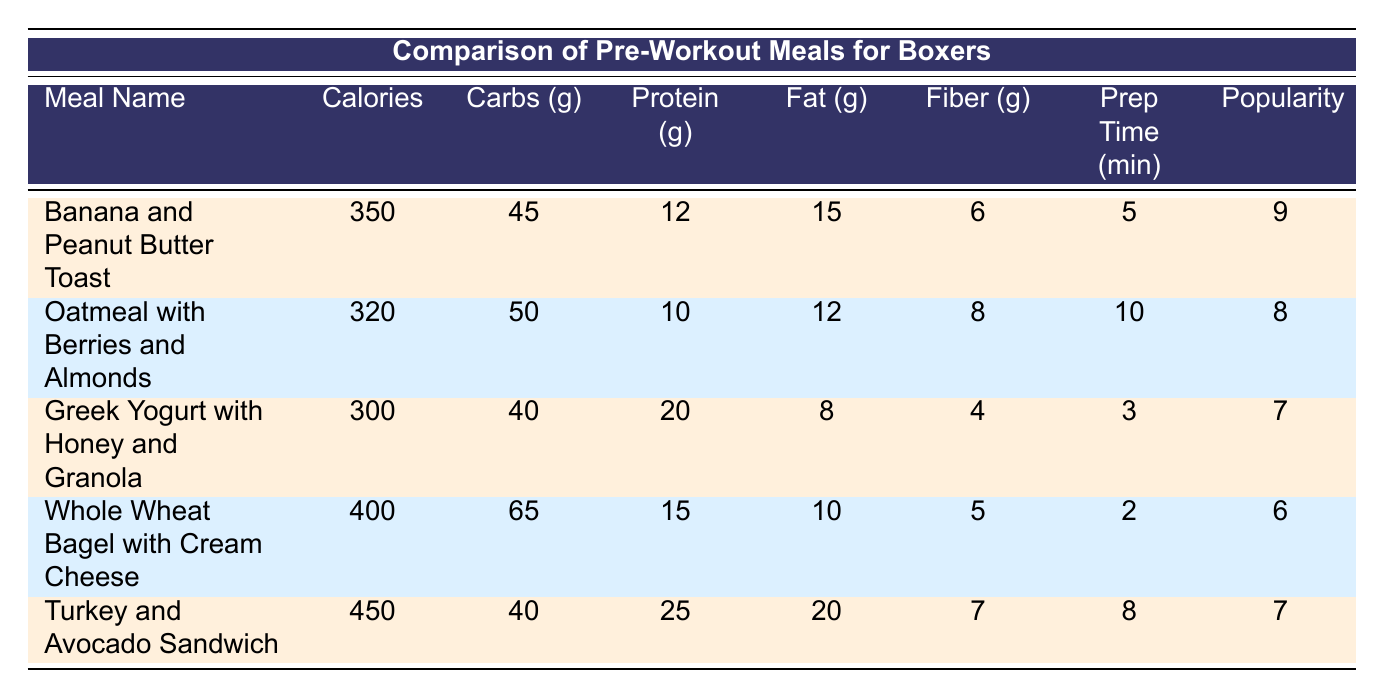What is the calorie content of the Turkey and Avocado Sandwich? The table shows that the Turkey and Avocado Sandwich has a calorie content of 450.
Answer: 450 Which meal is the least popular among boxers? According to the popularity ratings in the table, the Whole Wheat Bagel with Cream Cheese has the lowest rating of 6, making it the least popular meal among the options listed.
Answer: Whole Wheat Bagel with Cream Cheese How many grams of protein are in the Greek Yogurt with Honey and Granola? The Greek Yogurt with Honey and Granola contains 20 grams of protein as indicated in the protein column of the table.
Answer: 20 What is the average preparation time for all meals listed? The preparation times are 5, 10, 3, 2, and 8 minutes. The sum of these times is 38 minutes, and there are 5 meals, so the average is 38/5 = 7.6 minutes.
Answer: 7.6 Is the Banana and Peanut Butter Toast higher in calories than the Oatmeal with Berries and Almonds? Yes, the Banana and Peanut Butter Toast has 350 calories, while the Oatmeal with Berries and Almonds has 320 calories, confirming that the former is indeed higher.
Answer: Yes What is the difference in carbohydrate content between the Whole Wheat Bagel with Cream Cheese and the Turkey and Avocado Sandwich? The carbohydrate content for the Whole Wheat Bagel with Cream Cheese is 65 grams, and for the Turkey and Avocado Sandwich, it is 40 grams. The difference is 65 - 40 = 25 grams.
Answer: 25 Which meal has the highest protein content? Analyzing the protein column, the Turkey and Avocado Sandwich has 25 grams, which is higher than all other meals listed.
Answer: Turkey and Avocado Sandwich How much fiber does the Oatmeal with Berries and Almonds provide? From the table, the Oatmeal with Berries and Almonds provides 8 grams of fiber as shown in the fiber column.
Answer: 8 Is it true that all meals have more carbohydrates than fiber? Yes, by examining the carbohydrates and fiber columns, all meals listed indeed have higher carbohydrate content than fiber content.
Answer: Yes 